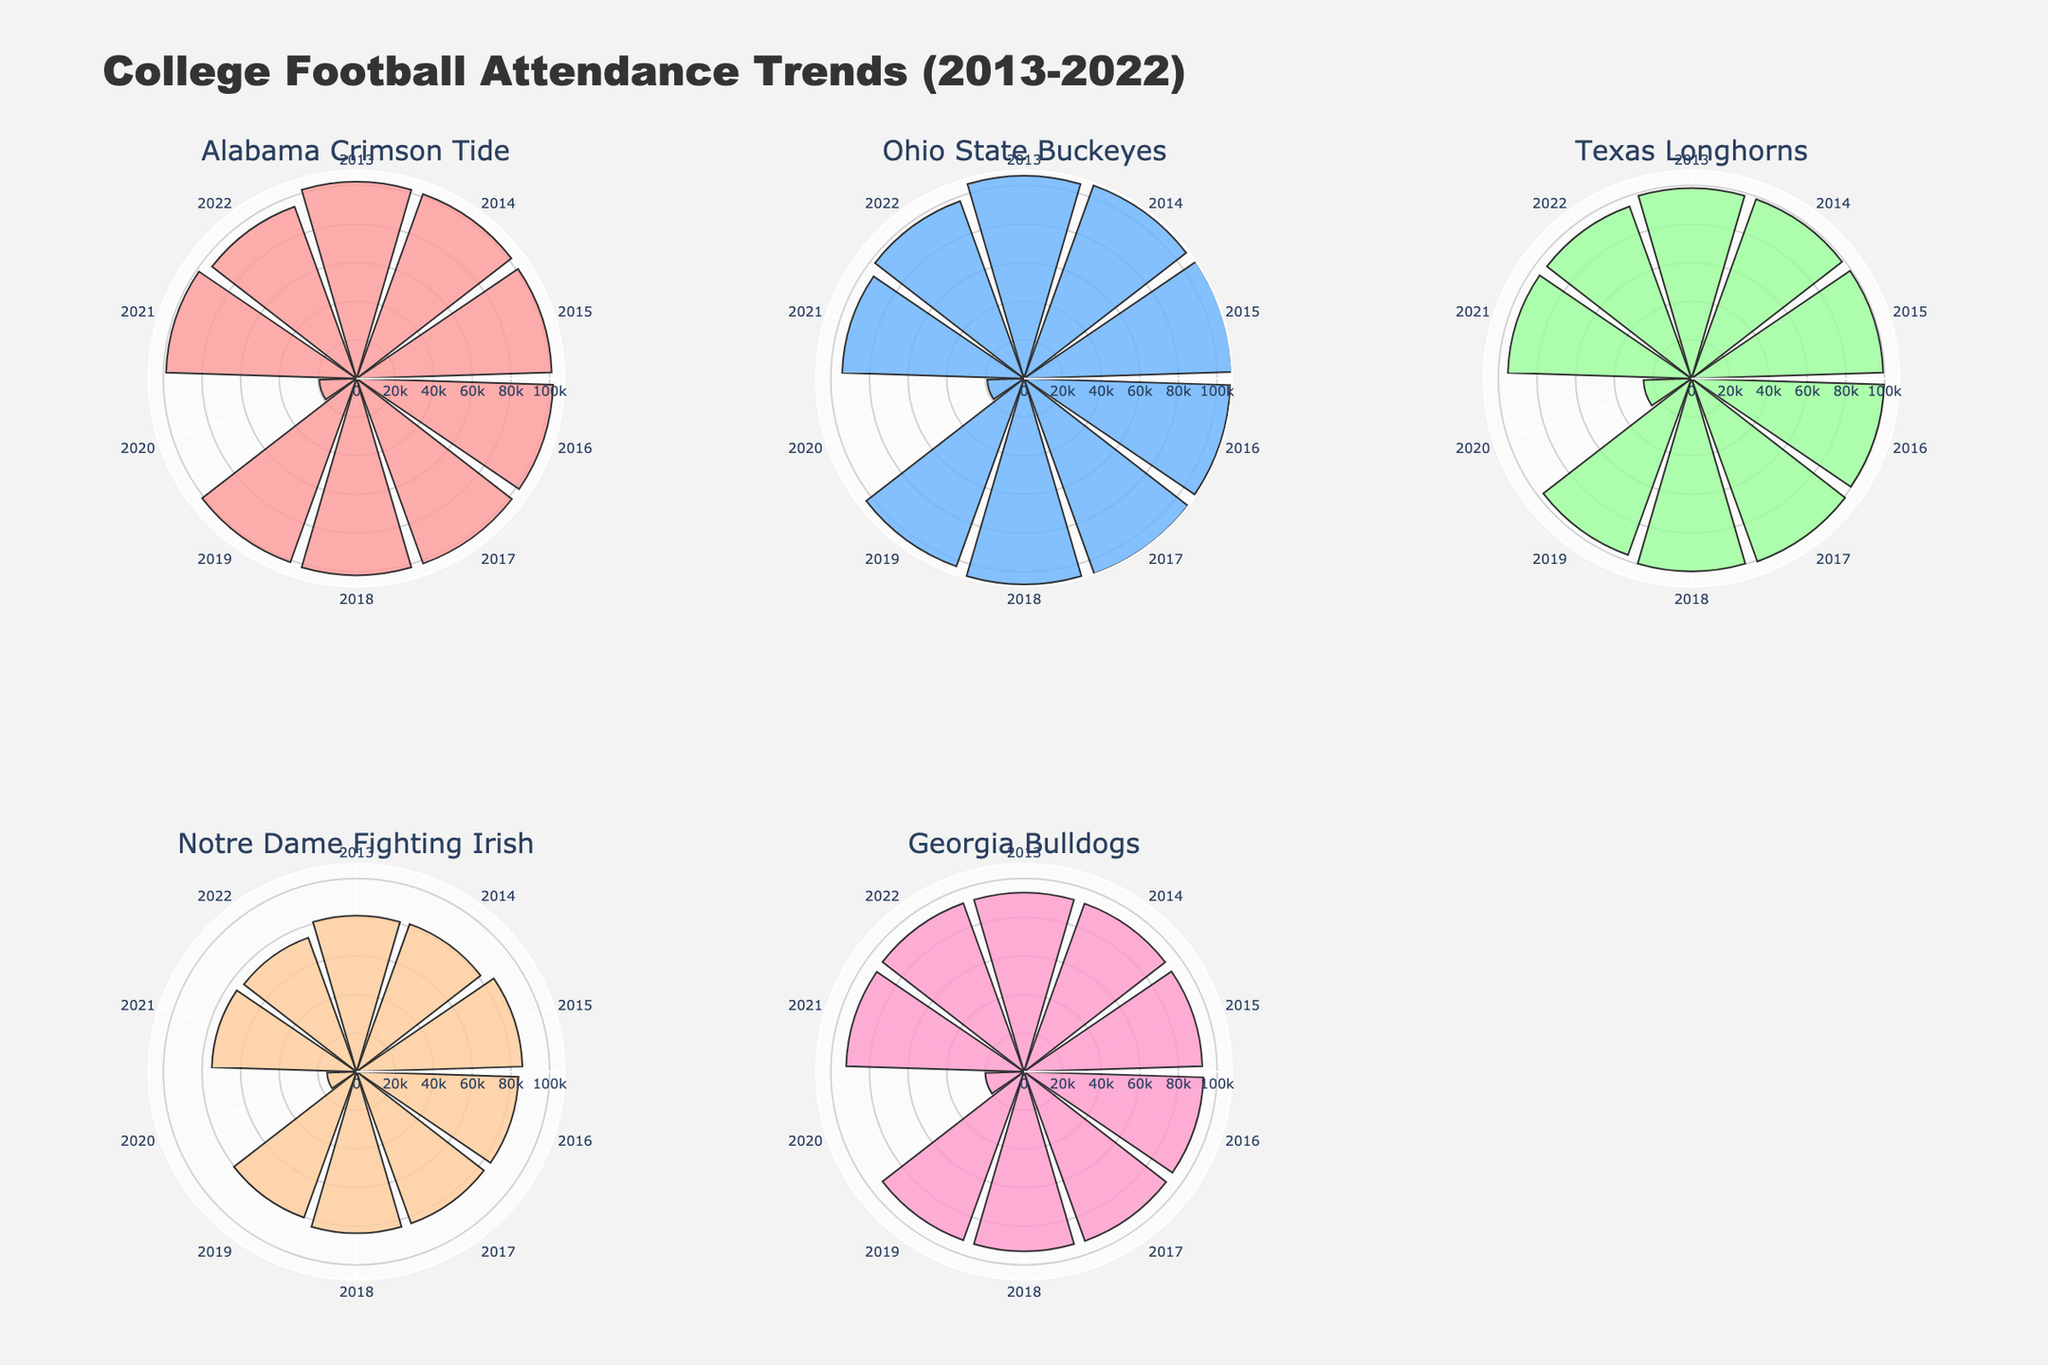How many teams are represented in the figure? There are six subplot titles, one for each team.
Answer: 6 Which team had the highest average attendance in 2014? Look at 2014, then compare the radial lengths for all teams. Ohio State Buckeyes have the longest bar.
Answer: Ohio State Buckeyes Which team shows the largest drop in attendance in 2019 compared to 2018? Compare radial lengths between 2018 and 2019 for all teams. The Ohio State Buckeyes show a noticeable drop.
Answer: Ohio State Buckeyes What major event likely affected attendance across all teams in 2020? The radial lengths for all teams in 2020 are significantly shorter, indicating a sharp decline in attendance.
Answer: COVID-19 pandemic Which team had a consistent attendance above 100,000 from 2013 to 2019? Check for a continuous segment of bars with lengths above 100,000 from 2013 to 2019 for each team. Alabama Crimson Tide and Ohio State Buckeyes meet this criterion.
Answer: Alabama Crimson Tide, Ohio State Buckeyes How did Georgia Bulldogs' 2021 attendance compare to its attendance in 2022? Compare the radial lengths for Georgia Bulldogs in 2021 and 2022. They are nearly the same length.
Answer: Nearly the same Which team had the lowest average attendance in 2020? Compare the shortest bar lengths for all teams in the year 2020. Notre Dame Fighting Irish has the shortest bar.
Answer: Notre Dame Fighting Irish Find the team with the most noticeable recovery in attendance from 2020 to 2021. Compare the increase in radial length from 2020 to 2021 for all teams. Alabama Crimson Tide shows a significant recovery, returning to a high level close to pre-pandemic numbers.
Answer: Alabama Crimson Tide Which year had the highest attendance for Texas Longhorns? Look for the longest radial length in the Texas Longhorns subplot. 2017 shows the longest bar.
Answer: 2017 How does Notre Dame Fighting Irish's attendance in 2013 compare to 2022? Compare the radial lengths for Notre Dame Fighting Irish in 2013 and 2022. The attendance in 2013 is higher than in 2022.
Answer: Higher in 2013 